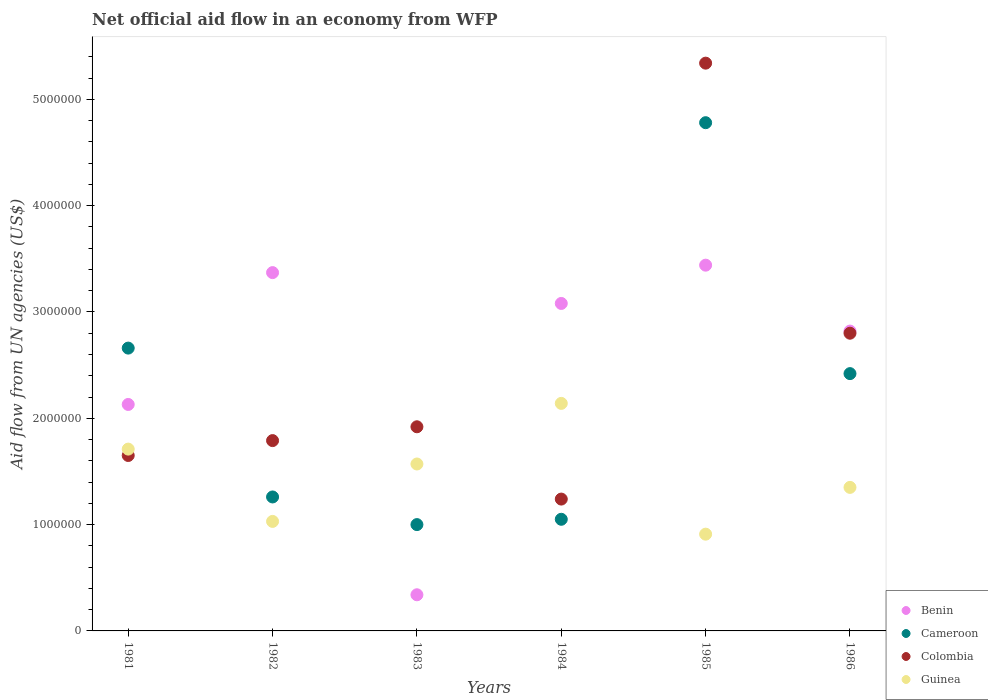Is the number of dotlines equal to the number of legend labels?
Your answer should be very brief. Yes. What is the net official aid flow in Guinea in 1981?
Ensure brevity in your answer.  1.71e+06. Across all years, what is the maximum net official aid flow in Cameroon?
Offer a very short reply. 4.78e+06. Across all years, what is the minimum net official aid flow in Guinea?
Provide a succinct answer. 9.10e+05. What is the total net official aid flow in Guinea in the graph?
Keep it short and to the point. 8.71e+06. What is the difference between the net official aid flow in Benin in 1981 and that in 1984?
Provide a succinct answer. -9.50e+05. What is the difference between the net official aid flow in Benin in 1981 and the net official aid flow in Guinea in 1982?
Keep it short and to the point. 1.10e+06. What is the average net official aid flow in Benin per year?
Keep it short and to the point. 2.53e+06. In the year 1985, what is the difference between the net official aid flow in Cameroon and net official aid flow in Benin?
Your response must be concise. 1.34e+06. What is the ratio of the net official aid flow in Colombia in 1981 to that in 1983?
Provide a succinct answer. 0.86. Is the net official aid flow in Colombia in 1983 less than that in 1985?
Make the answer very short. Yes. Is the difference between the net official aid flow in Cameroon in 1982 and 1984 greater than the difference between the net official aid flow in Benin in 1982 and 1984?
Ensure brevity in your answer.  No. What is the difference between the highest and the second highest net official aid flow in Benin?
Ensure brevity in your answer.  7.00e+04. What is the difference between the highest and the lowest net official aid flow in Colombia?
Offer a terse response. 4.10e+06. Is the sum of the net official aid flow in Cameroon in 1982 and 1986 greater than the maximum net official aid flow in Guinea across all years?
Your response must be concise. Yes. Is it the case that in every year, the sum of the net official aid flow in Guinea and net official aid flow in Cameroon  is greater than the sum of net official aid flow in Benin and net official aid flow in Colombia?
Your answer should be very brief. No. Does the net official aid flow in Benin monotonically increase over the years?
Provide a short and direct response. No. Is the net official aid flow in Cameroon strictly less than the net official aid flow in Guinea over the years?
Keep it short and to the point. No. How many years are there in the graph?
Your answer should be compact. 6. Where does the legend appear in the graph?
Your answer should be compact. Bottom right. How many legend labels are there?
Make the answer very short. 4. What is the title of the graph?
Your answer should be compact. Net official aid flow in an economy from WFP. What is the label or title of the Y-axis?
Offer a terse response. Aid flow from UN agencies (US$). What is the Aid flow from UN agencies (US$) of Benin in 1981?
Offer a very short reply. 2.13e+06. What is the Aid flow from UN agencies (US$) of Cameroon in 1981?
Offer a terse response. 2.66e+06. What is the Aid flow from UN agencies (US$) in Colombia in 1981?
Your answer should be very brief. 1.65e+06. What is the Aid flow from UN agencies (US$) in Guinea in 1981?
Offer a terse response. 1.71e+06. What is the Aid flow from UN agencies (US$) in Benin in 1982?
Provide a short and direct response. 3.37e+06. What is the Aid flow from UN agencies (US$) of Cameroon in 1982?
Offer a very short reply. 1.26e+06. What is the Aid flow from UN agencies (US$) of Colombia in 1982?
Your answer should be compact. 1.79e+06. What is the Aid flow from UN agencies (US$) of Guinea in 1982?
Provide a short and direct response. 1.03e+06. What is the Aid flow from UN agencies (US$) of Cameroon in 1983?
Make the answer very short. 1.00e+06. What is the Aid flow from UN agencies (US$) in Colombia in 1983?
Your response must be concise. 1.92e+06. What is the Aid flow from UN agencies (US$) in Guinea in 1983?
Make the answer very short. 1.57e+06. What is the Aid flow from UN agencies (US$) of Benin in 1984?
Make the answer very short. 3.08e+06. What is the Aid flow from UN agencies (US$) in Cameroon in 1984?
Make the answer very short. 1.05e+06. What is the Aid flow from UN agencies (US$) of Colombia in 1984?
Offer a very short reply. 1.24e+06. What is the Aid flow from UN agencies (US$) in Guinea in 1984?
Your answer should be very brief. 2.14e+06. What is the Aid flow from UN agencies (US$) in Benin in 1985?
Keep it short and to the point. 3.44e+06. What is the Aid flow from UN agencies (US$) in Cameroon in 1985?
Your answer should be very brief. 4.78e+06. What is the Aid flow from UN agencies (US$) of Colombia in 1985?
Offer a terse response. 5.34e+06. What is the Aid flow from UN agencies (US$) of Guinea in 1985?
Your answer should be compact. 9.10e+05. What is the Aid flow from UN agencies (US$) of Benin in 1986?
Your answer should be very brief. 2.82e+06. What is the Aid flow from UN agencies (US$) of Cameroon in 1986?
Give a very brief answer. 2.42e+06. What is the Aid flow from UN agencies (US$) in Colombia in 1986?
Provide a succinct answer. 2.80e+06. What is the Aid flow from UN agencies (US$) in Guinea in 1986?
Your answer should be very brief. 1.35e+06. Across all years, what is the maximum Aid flow from UN agencies (US$) in Benin?
Your answer should be very brief. 3.44e+06. Across all years, what is the maximum Aid flow from UN agencies (US$) of Cameroon?
Provide a succinct answer. 4.78e+06. Across all years, what is the maximum Aid flow from UN agencies (US$) of Colombia?
Your answer should be very brief. 5.34e+06. Across all years, what is the maximum Aid flow from UN agencies (US$) of Guinea?
Offer a terse response. 2.14e+06. Across all years, what is the minimum Aid flow from UN agencies (US$) of Benin?
Ensure brevity in your answer.  3.40e+05. Across all years, what is the minimum Aid flow from UN agencies (US$) of Colombia?
Your answer should be very brief. 1.24e+06. Across all years, what is the minimum Aid flow from UN agencies (US$) in Guinea?
Ensure brevity in your answer.  9.10e+05. What is the total Aid flow from UN agencies (US$) of Benin in the graph?
Keep it short and to the point. 1.52e+07. What is the total Aid flow from UN agencies (US$) of Cameroon in the graph?
Give a very brief answer. 1.32e+07. What is the total Aid flow from UN agencies (US$) in Colombia in the graph?
Ensure brevity in your answer.  1.47e+07. What is the total Aid flow from UN agencies (US$) of Guinea in the graph?
Your answer should be compact. 8.71e+06. What is the difference between the Aid flow from UN agencies (US$) of Benin in 1981 and that in 1982?
Make the answer very short. -1.24e+06. What is the difference between the Aid flow from UN agencies (US$) in Cameroon in 1981 and that in 1982?
Your answer should be compact. 1.40e+06. What is the difference between the Aid flow from UN agencies (US$) of Colombia in 1981 and that in 1982?
Give a very brief answer. -1.40e+05. What is the difference between the Aid flow from UN agencies (US$) of Guinea in 1981 and that in 1982?
Provide a succinct answer. 6.80e+05. What is the difference between the Aid flow from UN agencies (US$) in Benin in 1981 and that in 1983?
Give a very brief answer. 1.79e+06. What is the difference between the Aid flow from UN agencies (US$) of Cameroon in 1981 and that in 1983?
Offer a terse response. 1.66e+06. What is the difference between the Aid flow from UN agencies (US$) of Guinea in 1981 and that in 1983?
Provide a short and direct response. 1.40e+05. What is the difference between the Aid flow from UN agencies (US$) of Benin in 1981 and that in 1984?
Ensure brevity in your answer.  -9.50e+05. What is the difference between the Aid flow from UN agencies (US$) of Cameroon in 1981 and that in 1984?
Offer a very short reply. 1.61e+06. What is the difference between the Aid flow from UN agencies (US$) of Guinea in 1981 and that in 1984?
Your answer should be very brief. -4.30e+05. What is the difference between the Aid flow from UN agencies (US$) of Benin in 1981 and that in 1985?
Offer a terse response. -1.31e+06. What is the difference between the Aid flow from UN agencies (US$) in Cameroon in 1981 and that in 1985?
Your answer should be compact. -2.12e+06. What is the difference between the Aid flow from UN agencies (US$) in Colombia in 1981 and that in 1985?
Provide a short and direct response. -3.69e+06. What is the difference between the Aid flow from UN agencies (US$) in Guinea in 1981 and that in 1985?
Ensure brevity in your answer.  8.00e+05. What is the difference between the Aid flow from UN agencies (US$) in Benin in 1981 and that in 1986?
Your answer should be very brief. -6.90e+05. What is the difference between the Aid flow from UN agencies (US$) in Colombia in 1981 and that in 1986?
Provide a succinct answer. -1.15e+06. What is the difference between the Aid flow from UN agencies (US$) of Benin in 1982 and that in 1983?
Keep it short and to the point. 3.03e+06. What is the difference between the Aid flow from UN agencies (US$) in Guinea in 1982 and that in 1983?
Make the answer very short. -5.40e+05. What is the difference between the Aid flow from UN agencies (US$) in Benin in 1982 and that in 1984?
Offer a very short reply. 2.90e+05. What is the difference between the Aid flow from UN agencies (US$) in Cameroon in 1982 and that in 1984?
Make the answer very short. 2.10e+05. What is the difference between the Aid flow from UN agencies (US$) in Guinea in 1982 and that in 1984?
Ensure brevity in your answer.  -1.11e+06. What is the difference between the Aid flow from UN agencies (US$) of Benin in 1982 and that in 1985?
Keep it short and to the point. -7.00e+04. What is the difference between the Aid flow from UN agencies (US$) in Cameroon in 1982 and that in 1985?
Your answer should be very brief. -3.52e+06. What is the difference between the Aid flow from UN agencies (US$) in Colombia in 1982 and that in 1985?
Provide a short and direct response. -3.55e+06. What is the difference between the Aid flow from UN agencies (US$) of Guinea in 1982 and that in 1985?
Offer a terse response. 1.20e+05. What is the difference between the Aid flow from UN agencies (US$) in Benin in 1982 and that in 1986?
Your response must be concise. 5.50e+05. What is the difference between the Aid flow from UN agencies (US$) of Cameroon in 1982 and that in 1986?
Give a very brief answer. -1.16e+06. What is the difference between the Aid flow from UN agencies (US$) of Colombia in 1982 and that in 1986?
Offer a very short reply. -1.01e+06. What is the difference between the Aid flow from UN agencies (US$) of Guinea in 1982 and that in 1986?
Your answer should be very brief. -3.20e+05. What is the difference between the Aid flow from UN agencies (US$) of Benin in 1983 and that in 1984?
Your answer should be very brief. -2.74e+06. What is the difference between the Aid flow from UN agencies (US$) of Colombia in 1983 and that in 1984?
Ensure brevity in your answer.  6.80e+05. What is the difference between the Aid flow from UN agencies (US$) in Guinea in 1983 and that in 1984?
Make the answer very short. -5.70e+05. What is the difference between the Aid flow from UN agencies (US$) in Benin in 1983 and that in 1985?
Your answer should be compact. -3.10e+06. What is the difference between the Aid flow from UN agencies (US$) in Cameroon in 1983 and that in 1985?
Offer a terse response. -3.78e+06. What is the difference between the Aid flow from UN agencies (US$) in Colombia in 1983 and that in 1985?
Keep it short and to the point. -3.42e+06. What is the difference between the Aid flow from UN agencies (US$) in Guinea in 1983 and that in 1985?
Keep it short and to the point. 6.60e+05. What is the difference between the Aid flow from UN agencies (US$) in Benin in 1983 and that in 1986?
Provide a succinct answer. -2.48e+06. What is the difference between the Aid flow from UN agencies (US$) in Cameroon in 1983 and that in 1986?
Give a very brief answer. -1.42e+06. What is the difference between the Aid flow from UN agencies (US$) in Colombia in 1983 and that in 1986?
Your response must be concise. -8.80e+05. What is the difference between the Aid flow from UN agencies (US$) in Guinea in 1983 and that in 1986?
Provide a succinct answer. 2.20e+05. What is the difference between the Aid flow from UN agencies (US$) in Benin in 1984 and that in 1985?
Provide a succinct answer. -3.60e+05. What is the difference between the Aid flow from UN agencies (US$) in Cameroon in 1984 and that in 1985?
Provide a succinct answer. -3.73e+06. What is the difference between the Aid flow from UN agencies (US$) of Colombia in 1984 and that in 1985?
Your answer should be very brief. -4.10e+06. What is the difference between the Aid flow from UN agencies (US$) of Guinea in 1984 and that in 1985?
Your response must be concise. 1.23e+06. What is the difference between the Aid flow from UN agencies (US$) in Cameroon in 1984 and that in 1986?
Your answer should be compact. -1.37e+06. What is the difference between the Aid flow from UN agencies (US$) of Colombia in 1984 and that in 1986?
Keep it short and to the point. -1.56e+06. What is the difference between the Aid flow from UN agencies (US$) of Guinea in 1984 and that in 1986?
Offer a terse response. 7.90e+05. What is the difference between the Aid flow from UN agencies (US$) in Benin in 1985 and that in 1986?
Provide a succinct answer. 6.20e+05. What is the difference between the Aid flow from UN agencies (US$) in Cameroon in 1985 and that in 1986?
Ensure brevity in your answer.  2.36e+06. What is the difference between the Aid flow from UN agencies (US$) in Colombia in 1985 and that in 1986?
Your response must be concise. 2.54e+06. What is the difference between the Aid flow from UN agencies (US$) of Guinea in 1985 and that in 1986?
Provide a short and direct response. -4.40e+05. What is the difference between the Aid flow from UN agencies (US$) in Benin in 1981 and the Aid flow from UN agencies (US$) in Cameroon in 1982?
Provide a succinct answer. 8.70e+05. What is the difference between the Aid flow from UN agencies (US$) in Benin in 1981 and the Aid flow from UN agencies (US$) in Guinea in 1982?
Your response must be concise. 1.10e+06. What is the difference between the Aid flow from UN agencies (US$) of Cameroon in 1981 and the Aid flow from UN agencies (US$) of Colombia in 1982?
Make the answer very short. 8.70e+05. What is the difference between the Aid flow from UN agencies (US$) of Cameroon in 1981 and the Aid flow from UN agencies (US$) of Guinea in 1982?
Your answer should be very brief. 1.63e+06. What is the difference between the Aid flow from UN agencies (US$) in Colombia in 1981 and the Aid flow from UN agencies (US$) in Guinea in 1982?
Your answer should be very brief. 6.20e+05. What is the difference between the Aid flow from UN agencies (US$) in Benin in 1981 and the Aid flow from UN agencies (US$) in Cameroon in 1983?
Make the answer very short. 1.13e+06. What is the difference between the Aid flow from UN agencies (US$) in Benin in 1981 and the Aid flow from UN agencies (US$) in Colombia in 1983?
Give a very brief answer. 2.10e+05. What is the difference between the Aid flow from UN agencies (US$) in Benin in 1981 and the Aid flow from UN agencies (US$) in Guinea in 1983?
Your answer should be compact. 5.60e+05. What is the difference between the Aid flow from UN agencies (US$) of Cameroon in 1981 and the Aid flow from UN agencies (US$) of Colombia in 1983?
Give a very brief answer. 7.40e+05. What is the difference between the Aid flow from UN agencies (US$) of Cameroon in 1981 and the Aid flow from UN agencies (US$) of Guinea in 1983?
Offer a terse response. 1.09e+06. What is the difference between the Aid flow from UN agencies (US$) in Colombia in 1981 and the Aid flow from UN agencies (US$) in Guinea in 1983?
Make the answer very short. 8.00e+04. What is the difference between the Aid flow from UN agencies (US$) of Benin in 1981 and the Aid flow from UN agencies (US$) of Cameroon in 1984?
Offer a very short reply. 1.08e+06. What is the difference between the Aid flow from UN agencies (US$) of Benin in 1981 and the Aid flow from UN agencies (US$) of Colombia in 1984?
Provide a succinct answer. 8.90e+05. What is the difference between the Aid flow from UN agencies (US$) of Cameroon in 1981 and the Aid flow from UN agencies (US$) of Colombia in 1984?
Your answer should be compact. 1.42e+06. What is the difference between the Aid flow from UN agencies (US$) of Cameroon in 1981 and the Aid flow from UN agencies (US$) of Guinea in 1984?
Offer a terse response. 5.20e+05. What is the difference between the Aid flow from UN agencies (US$) of Colombia in 1981 and the Aid flow from UN agencies (US$) of Guinea in 1984?
Give a very brief answer. -4.90e+05. What is the difference between the Aid flow from UN agencies (US$) in Benin in 1981 and the Aid flow from UN agencies (US$) in Cameroon in 1985?
Your response must be concise. -2.65e+06. What is the difference between the Aid flow from UN agencies (US$) of Benin in 1981 and the Aid flow from UN agencies (US$) of Colombia in 1985?
Offer a very short reply. -3.21e+06. What is the difference between the Aid flow from UN agencies (US$) of Benin in 1981 and the Aid flow from UN agencies (US$) of Guinea in 1985?
Ensure brevity in your answer.  1.22e+06. What is the difference between the Aid flow from UN agencies (US$) of Cameroon in 1981 and the Aid flow from UN agencies (US$) of Colombia in 1985?
Provide a succinct answer. -2.68e+06. What is the difference between the Aid flow from UN agencies (US$) of Cameroon in 1981 and the Aid flow from UN agencies (US$) of Guinea in 1985?
Give a very brief answer. 1.75e+06. What is the difference between the Aid flow from UN agencies (US$) of Colombia in 1981 and the Aid flow from UN agencies (US$) of Guinea in 1985?
Ensure brevity in your answer.  7.40e+05. What is the difference between the Aid flow from UN agencies (US$) of Benin in 1981 and the Aid flow from UN agencies (US$) of Colombia in 1986?
Ensure brevity in your answer.  -6.70e+05. What is the difference between the Aid flow from UN agencies (US$) in Benin in 1981 and the Aid flow from UN agencies (US$) in Guinea in 1986?
Your answer should be compact. 7.80e+05. What is the difference between the Aid flow from UN agencies (US$) of Cameroon in 1981 and the Aid flow from UN agencies (US$) of Colombia in 1986?
Your response must be concise. -1.40e+05. What is the difference between the Aid flow from UN agencies (US$) in Cameroon in 1981 and the Aid flow from UN agencies (US$) in Guinea in 1986?
Offer a terse response. 1.31e+06. What is the difference between the Aid flow from UN agencies (US$) in Colombia in 1981 and the Aid flow from UN agencies (US$) in Guinea in 1986?
Ensure brevity in your answer.  3.00e+05. What is the difference between the Aid flow from UN agencies (US$) in Benin in 1982 and the Aid flow from UN agencies (US$) in Cameroon in 1983?
Your answer should be very brief. 2.37e+06. What is the difference between the Aid flow from UN agencies (US$) of Benin in 1982 and the Aid flow from UN agencies (US$) of Colombia in 1983?
Offer a terse response. 1.45e+06. What is the difference between the Aid flow from UN agencies (US$) in Benin in 1982 and the Aid flow from UN agencies (US$) in Guinea in 1983?
Give a very brief answer. 1.80e+06. What is the difference between the Aid flow from UN agencies (US$) in Cameroon in 1982 and the Aid flow from UN agencies (US$) in Colombia in 1983?
Give a very brief answer. -6.60e+05. What is the difference between the Aid flow from UN agencies (US$) in Cameroon in 1982 and the Aid flow from UN agencies (US$) in Guinea in 1983?
Give a very brief answer. -3.10e+05. What is the difference between the Aid flow from UN agencies (US$) in Colombia in 1982 and the Aid flow from UN agencies (US$) in Guinea in 1983?
Offer a very short reply. 2.20e+05. What is the difference between the Aid flow from UN agencies (US$) in Benin in 1982 and the Aid flow from UN agencies (US$) in Cameroon in 1984?
Your answer should be very brief. 2.32e+06. What is the difference between the Aid flow from UN agencies (US$) of Benin in 1982 and the Aid flow from UN agencies (US$) of Colombia in 1984?
Give a very brief answer. 2.13e+06. What is the difference between the Aid flow from UN agencies (US$) of Benin in 1982 and the Aid flow from UN agencies (US$) of Guinea in 1984?
Keep it short and to the point. 1.23e+06. What is the difference between the Aid flow from UN agencies (US$) of Cameroon in 1982 and the Aid flow from UN agencies (US$) of Colombia in 1984?
Your response must be concise. 2.00e+04. What is the difference between the Aid flow from UN agencies (US$) in Cameroon in 1982 and the Aid flow from UN agencies (US$) in Guinea in 1984?
Keep it short and to the point. -8.80e+05. What is the difference between the Aid flow from UN agencies (US$) in Colombia in 1982 and the Aid flow from UN agencies (US$) in Guinea in 1984?
Provide a succinct answer. -3.50e+05. What is the difference between the Aid flow from UN agencies (US$) in Benin in 1982 and the Aid flow from UN agencies (US$) in Cameroon in 1985?
Your answer should be compact. -1.41e+06. What is the difference between the Aid flow from UN agencies (US$) of Benin in 1982 and the Aid flow from UN agencies (US$) of Colombia in 1985?
Your answer should be very brief. -1.97e+06. What is the difference between the Aid flow from UN agencies (US$) in Benin in 1982 and the Aid flow from UN agencies (US$) in Guinea in 1985?
Provide a short and direct response. 2.46e+06. What is the difference between the Aid flow from UN agencies (US$) of Cameroon in 1982 and the Aid flow from UN agencies (US$) of Colombia in 1985?
Give a very brief answer. -4.08e+06. What is the difference between the Aid flow from UN agencies (US$) in Colombia in 1982 and the Aid flow from UN agencies (US$) in Guinea in 1985?
Your answer should be compact. 8.80e+05. What is the difference between the Aid flow from UN agencies (US$) of Benin in 1982 and the Aid flow from UN agencies (US$) of Cameroon in 1986?
Your answer should be very brief. 9.50e+05. What is the difference between the Aid flow from UN agencies (US$) in Benin in 1982 and the Aid flow from UN agencies (US$) in Colombia in 1986?
Provide a short and direct response. 5.70e+05. What is the difference between the Aid flow from UN agencies (US$) of Benin in 1982 and the Aid flow from UN agencies (US$) of Guinea in 1986?
Give a very brief answer. 2.02e+06. What is the difference between the Aid flow from UN agencies (US$) in Cameroon in 1982 and the Aid flow from UN agencies (US$) in Colombia in 1986?
Provide a short and direct response. -1.54e+06. What is the difference between the Aid flow from UN agencies (US$) of Colombia in 1982 and the Aid flow from UN agencies (US$) of Guinea in 1986?
Offer a terse response. 4.40e+05. What is the difference between the Aid flow from UN agencies (US$) in Benin in 1983 and the Aid flow from UN agencies (US$) in Cameroon in 1984?
Keep it short and to the point. -7.10e+05. What is the difference between the Aid flow from UN agencies (US$) of Benin in 1983 and the Aid flow from UN agencies (US$) of Colombia in 1984?
Give a very brief answer. -9.00e+05. What is the difference between the Aid flow from UN agencies (US$) in Benin in 1983 and the Aid flow from UN agencies (US$) in Guinea in 1984?
Provide a short and direct response. -1.80e+06. What is the difference between the Aid flow from UN agencies (US$) in Cameroon in 1983 and the Aid flow from UN agencies (US$) in Guinea in 1984?
Your answer should be very brief. -1.14e+06. What is the difference between the Aid flow from UN agencies (US$) of Colombia in 1983 and the Aid flow from UN agencies (US$) of Guinea in 1984?
Offer a very short reply. -2.20e+05. What is the difference between the Aid flow from UN agencies (US$) in Benin in 1983 and the Aid flow from UN agencies (US$) in Cameroon in 1985?
Provide a succinct answer. -4.44e+06. What is the difference between the Aid flow from UN agencies (US$) of Benin in 1983 and the Aid flow from UN agencies (US$) of Colombia in 1985?
Keep it short and to the point. -5.00e+06. What is the difference between the Aid flow from UN agencies (US$) in Benin in 1983 and the Aid flow from UN agencies (US$) in Guinea in 1985?
Provide a succinct answer. -5.70e+05. What is the difference between the Aid flow from UN agencies (US$) of Cameroon in 1983 and the Aid flow from UN agencies (US$) of Colombia in 1985?
Provide a succinct answer. -4.34e+06. What is the difference between the Aid flow from UN agencies (US$) of Colombia in 1983 and the Aid flow from UN agencies (US$) of Guinea in 1985?
Ensure brevity in your answer.  1.01e+06. What is the difference between the Aid flow from UN agencies (US$) in Benin in 1983 and the Aid flow from UN agencies (US$) in Cameroon in 1986?
Ensure brevity in your answer.  -2.08e+06. What is the difference between the Aid flow from UN agencies (US$) of Benin in 1983 and the Aid flow from UN agencies (US$) of Colombia in 1986?
Keep it short and to the point. -2.46e+06. What is the difference between the Aid flow from UN agencies (US$) in Benin in 1983 and the Aid flow from UN agencies (US$) in Guinea in 1986?
Your response must be concise. -1.01e+06. What is the difference between the Aid flow from UN agencies (US$) of Cameroon in 1983 and the Aid flow from UN agencies (US$) of Colombia in 1986?
Keep it short and to the point. -1.80e+06. What is the difference between the Aid flow from UN agencies (US$) in Cameroon in 1983 and the Aid flow from UN agencies (US$) in Guinea in 1986?
Offer a very short reply. -3.50e+05. What is the difference between the Aid flow from UN agencies (US$) of Colombia in 1983 and the Aid flow from UN agencies (US$) of Guinea in 1986?
Your response must be concise. 5.70e+05. What is the difference between the Aid flow from UN agencies (US$) of Benin in 1984 and the Aid flow from UN agencies (US$) of Cameroon in 1985?
Your response must be concise. -1.70e+06. What is the difference between the Aid flow from UN agencies (US$) of Benin in 1984 and the Aid flow from UN agencies (US$) of Colombia in 1985?
Offer a very short reply. -2.26e+06. What is the difference between the Aid flow from UN agencies (US$) of Benin in 1984 and the Aid flow from UN agencies (US$) of Guinea in 1985?
Keep it short and to the point. 2.17e+06. What is the difference between the Aid flow from UN agencies (US$) of Cameroon in 1984 and the Aid flow from UN agencies (US$) of Colombia in 1985?
Offer a very short reply. -4.29e+06. What is the difference between the Aid flow from UN agencies (US$) in Cameroon in 1984 and the Aid flow from UN agencies (US$) in Guinea in 1985?
Provide a succinct answer. 1.40e+05. What is the difference between the Aid flow from UN agencies (US$) in Benin in 1984 and the Aid flow from UN agencies (US$) in Cameroon in 1986?
Give a very brief answer. 6.60e+05. What is the difference between the Aid flow from UN agencies (US$) of Benin in 1984 and the Aid flow from UN agencies (US$) of Colombia in 1986?
Offer a very short reply. 2.80e+05. What is the difference between the Aid flow from UN agencies (US$) of Benin in 1984 and the Aid flow from UN agencies (US$) of Guinea in 1986?
Provide a succinct answer. 1.73e+06. What is the difference between the Aid flow from UN agencies (US$) of Cameroon in 1984 and the Aid flow from UN agencies (US$) of Colombia in 1986?
Offer a terse response. -1.75e+06. What is the difference between the Aid flow from UN agencies (US$) of Colombia in 1984 and the Aid flow from UN agencies (US$) of Guinea in 1986?
Keep it short and to the point. -1.10e+05. What is the difference between the Aid flow from UN agencies (US$) of Benin in 1985 and the Aid flow from UN agencies (US$) of Cameroon in 1986?
Your answer should be compact. 1.02e+06. What is the difference between the Aid flow from UN agencies (US$) of Benin in 1985 and the Aid flow from UN agencies (US$) of Colombia in 1986?
Make the answer very short. 6.40e+05. What is the difference between the Aid flow from UN agencies (US$) of Benin in 1985 and the Aid flow from UN agencies (US$) of Guinea in 1986?
Ensure brevity in your answer.  2.09e+06. What is the difference between the Aid flow from UN agencies (US$) of Cameroon in 1985 and the Aid flow from UN agencies (US$) of Colombia in 1986?
Offer a terse response. 1.98e+06. What is the difference between the Aid flow from UN agencies (US$) of Cameroon in 1985 and the Aid flow from UN agencies (US$) of Guinea in 1986?
Make the answer very short. 3.43e+06. What is the difference between the Aid flow from UN agencies (US$) of Colombia in 1985 and the Aid flow from UN agencies (US$) of Guinea in 1986?
Offer a terse response. 3.99e+06. What is the average Aid flow from UN agencies (US$) of Benin per year?
Ensure brevity in your answer.  2.53e+06. What is the average Aid flow from UN agencies (US$) of Cameroon per year?
Your answer should be compact. 2.20e+06. What is the average Aid flow from UN agencies (US$) in Colombia per year?
Your answer should be compact. 2.46e+06. What is the average Aid flow from UN agencies (US$) of Guinea per year?
Keep it short and to the point. 1.45e+06. In the year 1981, what is the difference between the Aid flow from UN agencies (US$) of Benin and Aid flow from UN agencies (US$) of Cameroon?
Provide a succinct answer. -5.30e+05. In the year 1981, what is the difference between the Aid flow from UN agencies (US$) of Benin and Aid flow from UN agencies (US$) of Colombia?
Keep it short and to the point. 4.80e+05. In the year 1981, what is the difference between the Aid flow from UN agencies (US$) in Cameroon and Aid flow from UN agencies (US$) in Colombia?
Your response must be concise. 1.01e+06. In the year 1981, what is the difference between the Aid flow from UN agencies (US$) of Cameroon and Aid flow from UN agencies (US$) of Guinea?
Make the answer very short. 9.50e+05. In the year 1982, what is the difference between the Aid flow from UN agencies (US$) in Benin and Aid flow from UN agencies (US$) in Cameroon?
Offer a terse response. 2.11e+06. In the year 1982, what is the difference between the Aid flow from UN agencies (US$) of Benin and Aid flow from UN agencies (US$) of Colombia?
Your answer should be compact. 1.58e+06. In the year 1982, what is the difference between the Aid flow from UN agencies (US$) in Benin and Aid flow from UN agencies (US$) in Guinea?
Offer a very short reply. 2.34e+06. In the year 1982, what is the difference between the Aid flow from UN agencies (US$) of Cameroon and Aid flow from UN agencies (US$) of Colombia?
Your answer should be compact. -5.30e+05. In the year 1982, what is the difference between the Aid flow from UN agencies (US$) of Cameroon and Aid flow from UN agencies (US$) of Guinea?
Ensure brevity in your answer.  2.30e+05. In the year 1982, what is the difference between the Aid flow from UN agencies (US$) in Colombia and Aid flow from UN agencies (US$) in Guinea?
Offer a terse response. 7.60e+05. In the year 1983, what is the difference between the Aid flow from UN agencies (US$) in Benin and Aid flow from UN agencies (US$) in Cameroon?
Provide a short and direct response. -6.60e+05. In the year 1983, what is the difference between the Aid flow from UN agencies (US$) of Benin and Aid flow from UN agencies (US$) of Colombia?
Offer a very short reply. -1.58e+06. In the year 1983, what is the difference between the Aid flow from UN agencies (US$) in Benin and Aid flow from UN agencies (US$) in Guinea?
Your response must be concise. -1.23e+06. In the year 1983, what is the difference between the Aid flow from UN agencies (US$) of Cameroon and Aid flow from UN agencies (US$) of Colombia?
Offer a very short reply. -9.20e+05. In the year 1983, what is the difference between the Aid flow from UN agencies (US$) of Cameroon and Aid flow from UN agencies (US$) of Guinea?
Your response must be concise. -5.70e+05. In the year 1983, what is the difference between the Aid flow from UN agencies (US$) in Colombia and Aid flow from UN agencies (US$) in Guinea?
Offer a terse response. 3.50e+05. In the year 1984, what is the difference between the Aid flow from UN agencies (US$) of Benin and Aid flow from UN agencies (US$) of Cameroon?
Offer a very short reply. 2.03e+06. In the year 1984, what is the difference between the Aid flow from UN agencies (US$) of Benin and Aid flow from UN agencies (US$) of Colombia?
Keep it short and to the point. 1.84e+06. In the year 1984, what is the difference between the Aid flow from UN agencies (US$) in Benin and Aid flow from UN agencies (US$) in Guinea?
Your answer should be compact. 9.40e+05. In the year 1984, what is the difference between the Aid flow from UN agencies (US$) of Cameroon and Aid flow from UN agencies (US$) of Guinea?
Your answer should be compact. -1.09e+06. In the year 1984, what is the difference between the Aid flow from UN agencies (US$) of Colombia and Aid flow from UN agencies (US$) of Guinea?
Offer a terse response. -9.00e+05. In the year 1985, what is the difference between the Aid flow from UN agencies (US$) of Benin and Aid flow from UN agencies (US$) of Cameroon?
Your answer should be very brief. -1.34e+06. In the year 1985, what is the difference between the Aid flow from UN agencies (US$) of Benin and Aid flow from UN agencies (US$) of Colombia?
Give a very brief answer. -1.90e+06. In the year 1985, what is the difference between the Aid flow from UN agencies (US$) in Benin and Aid flow from UN agencies (US$) in Guinea?
Your answer should be very brief. 2.53e+06. In the year 1985, what is the difference between the Aid flow from UN agencies (US$) of Cameroon and Aid flow from UN agencies (US$) of Colombia?
Offer a terse response. -5.60e+05. In the year 1985, what is the difference between the Aid flow from UN agencies (US$) in Cameroon and Aid flow from UN agencies (US$) in Guinea?
Make the answer very short. 3.87e+06. In the year 1985, what is the difference between the Aid flow from UN agencies (US$) in Colombia and Aid flow from UN agencies (US$) in Guinea?
Make the answer very short. 4.43e+06. In the year 1986, what is the difference between the Aid flow from UN agencies (US$) of Benin and Aid flow from UN agencies (US$) of Colombia?
Your answer should be very brief. 2.00e+04. In the year 1986, what is the difference between the Aid flow from UN agencies (US$) in Benin and Aid flow from UN agencies (US$) in Guinea?
Your response must be concise. 1.47e+06. In the year 1986, what is the difference between the Aid flow from UN agencies (US$) of Cameroon and Aid flow from UN agencies (US$) of Colombia?
Offer a very short reply. -3.80e+05. In the year 1986, what is the difference between the Aid flow from UN agencies (US$) in Cameroon and Aid flow from UN agencies (US$) in Guinea?
Offer a terse response. 1.07e+06. In the year 1986, what is the difference between the Aid flow from UN agencies (US$) of Colombia and Aid flow from UN agencies (US$) of Guinea?
Your answer should be compact. 1.45e+06. What is the ratio of the Aid flow from UN agencies (US$) of Benin in 1981 to that in 1982?
Provide a short and direct response. 0.63. What is the ratio of the Aid flow from UN agencies (US$) of Cameroon in 1981 to that in 1982?
Your response must be concise. 2.11. What is the ratio of the Aid flow from UN agencies (US$) in Colombia in 1981 to that in 1982?
Make the answer very short. 0.92. What is the ratio of the Aid flow from UN agencies (US$) of Guinea in 1981 to that in 1982?
Provide a succinct answer. 1.66. What is the ratio of the Aid flow from UN agencies (US$) of Benin in 1981 to that in 1983?
Give a very brief answer. 6.26. What is the ratio of the Aid flow from UN agencies (US$) in Cameroon in 1981 to that in 1983?
Provide a succinct answer. 2.66. What is the ratio of the Aid flow from UN agencies (US$) of Colombia in 1981 to that in 1983?
Your answer should be very brief. 0.86. What is the ratio of the Aid flow from UN agencies (US$) in Guinea in 1981 to that in 1983?
Your answer should be very brief. 1.09. What is the ratio of the Aid flow from UN agencies (US$) in Benin in 1981 to that in 1984?
Offer a very short reply. 0.69. What is the ratio of the Aid flow from UN agencies (US$) in Cameroon in 1981 to that in 1984?
Provide a short and direct response. 2.53. What is the ratio of the Aid flow from UN agencies (US$) in Colombia in 1981 to that in 1984?
Offer a terse response. 1.33. What is the ratio of the Aid flow from UN agencies (US$) of Guinea in 1981 to that in 1984?
Give a very brief answer. 0.8. What is the ratio of the Aid flow from UN agencies (US$) of Benin in 1981 to that in 1985?
Ensure brevity in your answer.  0.62. What is the ratio of the Aid flow from UN agencies (US$) of Cameroon in 1981 to that in 1985?
Make the answer very short. 0.56. What is the ratio of the Aid flow from UN agencies (US$) in Colombia in 1981 to that in 1985?
Provide a succinct answer. 0.31. What is the ratio of the Aid flow from UN agencies (US$) of Guinea in 1981 to that in 1985?
Provide a succinct answer. 1.88. What is the ratio of the Aid flow from UN agencies (US$) in Benin in 1981 to that in 1986?
Offer a very short reply. 0.76. What is the ratio of the Aid flow from UN agencies (US$) of Cameroon in 1981 to that in 1986?
Give a very brief answer. 1.1. What is the ratio of the Aid flow from UN agencies (US$) in Colombia in 1981 to that in 1986?
Keep it short and to the point. 0.59. What is the ratio of the Aid flow from UN agencies (US$) of Guinea in 1981 to that in 1986?
Keep it short and to the point. 1.27. What is the ratio of the Aid flow from UN agencies (US$) in Benin in 1982 to that in 1983?
Your response must be concise. 9.91. What is the ratio of the Aid flow from UN agencies (US$) in Cameroon in 1982 to that in 1983?
Your answer should be compact. 1.26. What is the ratio of the Aid flow from UN agencies (US$) in Colombia in 1982 to that in 1983?
Keep it short and to the point. 0.93. What is the ratio of the Aid flow from UN agencies (US$) of Guinea in 1982 to that in 1983?
Provide a succinct answer. 0.66. What is the ratio of the Aid flow from UN agencies (US$) in Benin in 1982 to that in 1984?
Provide a succinct answer. 1.09. What is the ratio of the Aid flow from UN agencies (US$) of Cameroon in 1982 to that in 1984?
Your response must be concise. 1.2. What is the ratio of the Aid flow from UN agencies (US$) of Colombia in 1982 to that in 1984?
Offer a very short reply. 1.44. What is the ratio of the Aid flow from UN agencies (US$) in Guinea in 1982 to that in 1984?
Make the answer very short. 0.48. What is the ratio of the Aid flow from UN agencies (US$) in Benin in 1982 to that in 1985?
Make the answer very short. 0.98. What is the ratio of the Aid flow from UN agencies (US$) in Cameroon in 1982 to that in 1985?
Your answer should be very brief. 0.26. What is the ratio of the Aid flow from UN agencies (US$) of Colombia in 1982 to that in 1985?
Offer a terse response. 0.34. What is the ratio of the Aid flow from UN agencies (US$) of Guinea in 1982 to that in 1985?
Give a very brief answer. 1.13. What is the ratio of the Aid flow from UN agencies (US$) of Benin in 1982 to that in 1986?
Give a very brief answer. 1.2. What is the ratio of the Aid flow from UN agencies (US$) of Cameroon in 1982 to that in 1986?
Offer a very short reply. 0.52. What is the ratio of the Aid flow from UN agencies (US$) in Colombia in 1982 to that in 1986?
Provide a succinct answer. 0.64. What is the ratio of the Aid flow from UN agencies (US$) of Guinea in 1982 to that in 1986?
Your answer should be very brief. 0.76. What is the ratio of the Aid flow from UN agencies (US$) in Benin in 1983 to that in 1984?
Keep it short and to the point. 0.11. What is the ratio of the Aid flow from UN agencies (US$) in Cameroon in 1983 to that in 1984?
Provide a short and direct response. 0.95. What is the ratio of the Aid flow from UN agencies (US$) in Colombia in 1983 to that in 1984?
Provide a short and direct response. 1.55. What is the ratio of the Aid flow from UN agencies (US$) of Guinea in 1983 to that in 1984?
Offer a very short reply. 0.73. What is the ratio of the Aid flow from UN agencies (US$) in Benin in 1983 to that in 1985?
Provide a short and direct response. 0.1. What is the ratio of the Aid flow from UN agencies (US$) in Cameroon in 1983 to that in 1985?
Give a very brief answer. 0.21. What is the ratio of the Aid flow from UN agencies (US$) of Colombia in 1983 to that in 1985?
Your answer should be very brief. 0.36. What is the ratio of the Aid flow from UN agencies (US$) of Guinea in 1983 to that in 1985?
Your response must be concise. 1.73. What is the ratio of the Aid flow from UN agencies (US$) of Benin in 1983 to that in 1986?
Offer a very short reply. 0.12. What is the ratio of the Aid flow from UN agencies (US$) of Cameroon in 1983 to that in 1986?
Your response must be concise. 0.41. What is the ratio of the Aid flow from UN agencies (US$) of Colombia in 1983 to that in 1986?
Make the answer very short. 0.69. What is the ratio of the Aid flow from UN agencies (US$) of Guinea in 1983 to that in 1986?
Give a very brief answer. 1.16. What is the ratio of the Aid flow from UN agencies (US$) in Benin in 1984 to that in 1985?
Your answer should be compact. 0.9. What is the ratio of the Aid flow from UN agencies (US$) of Cameroon in 1984 to that in 1985?
Give a very brief answer. 0.22. What is the ratio of the Aid flow from UN agencies (US$) in Colombia in 1984 to that in 1985?
Offer a very short reply. 0.23. What is the ratio of the Aid flow from UN agencies (US$) of Guinea in 1984 to that in 1985?
Your response must be concise. 2.35. What is the ratio of the Aid flow from UN agencies (US$) in Benin in 1984 to that in 1986?
Give a very brief answer. 1.09. What is the ratio of the Aid flow from UN agencies (US$) of Cameroon in 1984 to that in 1986?
Offer a very short reply. 0.43. What is the ratio of the Aid flow from UN agencies (US$) in Colombia in 1984 to that in 1986?
Provide a succinct answer. 0.44. What is the ratio of the Aid flow from UN agencies (US$) in Guinea in 1984 to that in 1986?
Offer a terse response. 1.59. What is the ratio of the Aid flow from UN agencies (US$) of Benin in 1985 to that in 1986?
Offer a very short reply. 1.22. What is the ratio of the Aid flow from UN agencies (US$) of Cameroon in 1985 to that in 1986?
Your answer should be compact. 1.98. What is the ratio of the Aid flow from UN agencies (US$) in Colombia in 1985 to that in 1986?
Your answer should be very brief. 1.91. What is the ratio of the Aid flow from UN agencies (US$) in Guinea in 1985 to that in 1986?
Offer a very short reply. 0.67. What is the difference between the highest and the second highest Aid flow from UN agencies (US$) in Cameroon?
Keep it short and to the point. 2.12e+06. What is the difference between the highest and the second highest Aid flow from UN agencies (US$) in Colombia?
Keep it short and to the point. 2.54e+06. What is the difference between the highest and the lowest Aid flow from UN agencies (US$) of Benin?
Offer a terse response. 3.10e+06. What is the difference between the highest and the lowest Aid flow from UN agencies (US$) in Cameroon?
Make the answer very short. 3.78e+06. What is the difference between the highest and the lowest Aid flow from UN agencies (US$) of Colombia?
Give a very brief answer. 4.10e+06. What is the difference between the highest and the lowest Aid flow from UN agencies (US$) in Guinea?
Your answer should be compact. 1.23e+06. 